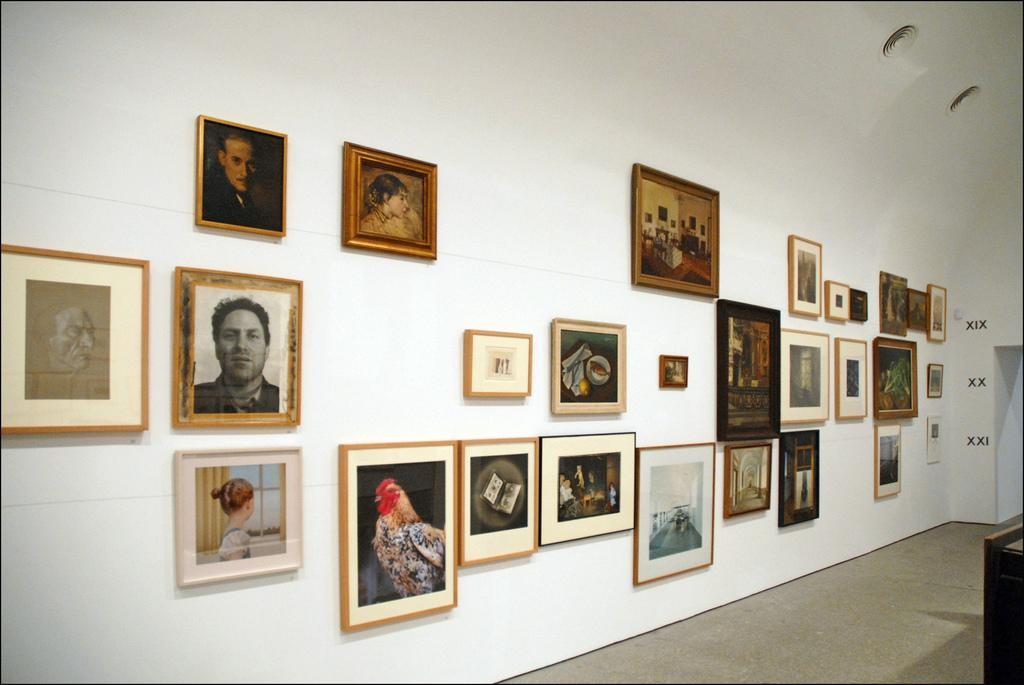What is present on the wall in the image? There are photo frames attached to the wall. What can be seen in the photo frames? The photo frames contain images of people and animals. What type of curve can be seen in the image? There is no curve present in the image; it features a wall with photo frames. 